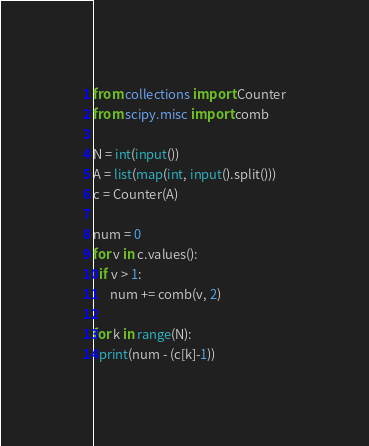Convert code to text. <code><loc_0><loc_0><loc_500><loc_500><_Python_>from collections import Counter
from scipy.misc import comb

N = int(input())
A = list(map(int, input().split()))
c = Counter(A)

num = 0
for v in c.values():
  if v > 1:
      num += comb(v, 2)

for k in range(N):
  print(num - (c[k]-1))</code> 